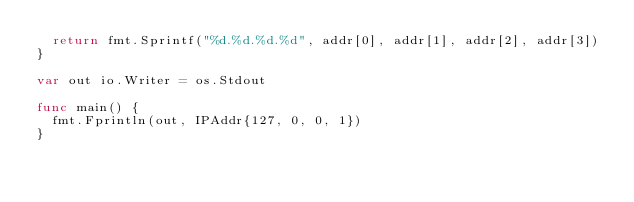Convert code to text. <code><loc_0><loc_0><loc_500><loc_500><_Go_>	return fmt.Sprintf("%d.%d.%d.%d", addr[0], addr[1], addr[2], addr[3])
}

var out io.Writer = os.Stdout

func main() {
	fmt.Fprintln(out, IPAddr{127, 0, 0, 1})
}
</code> 